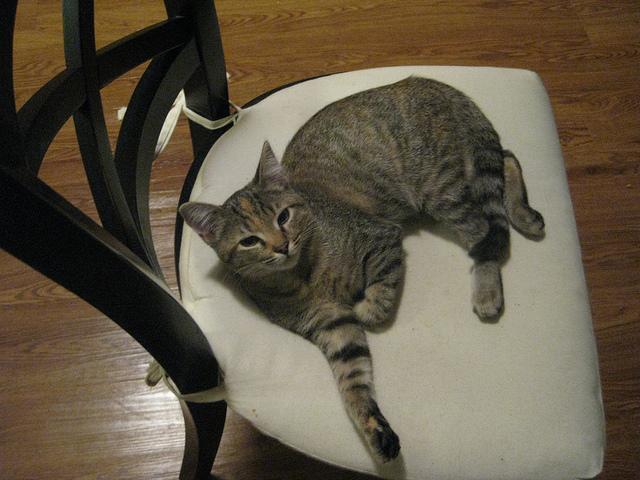How many cats are there?
Give a very brief answer. 1. 